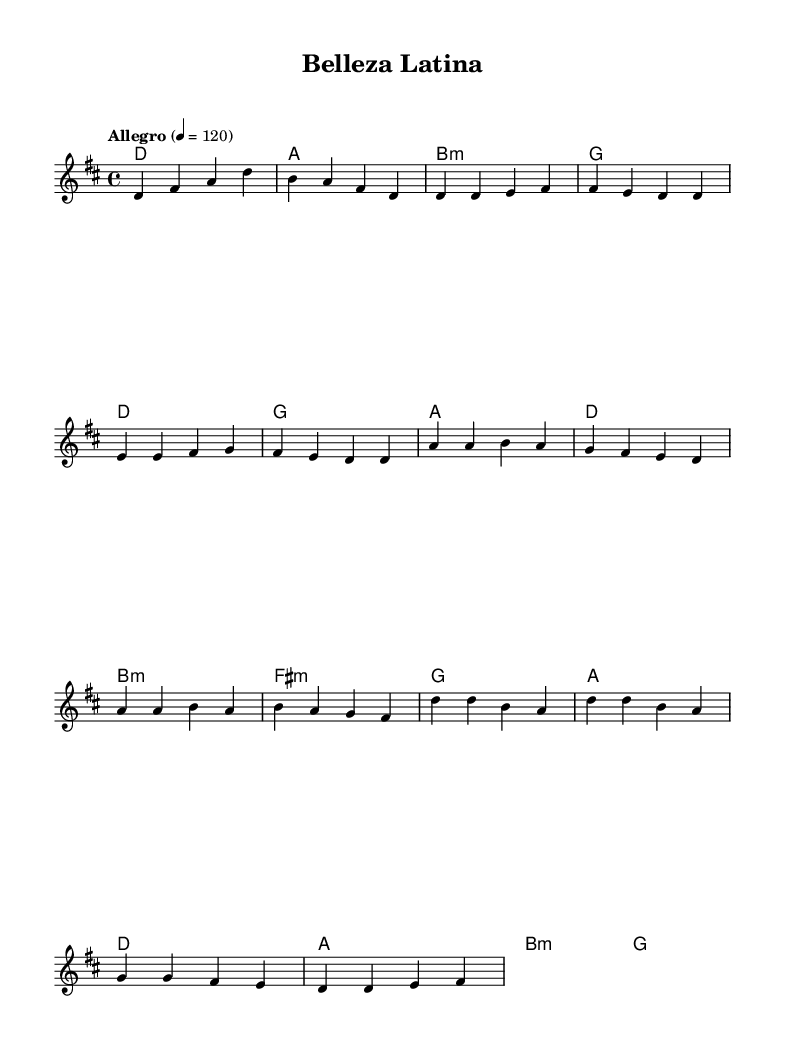What is the key signature of this music? The key signature indicates that the piece is in D major, which has two sharps: F# and C#. You can identify the key signature at the beginning of the staff, where the sharps are written.
Answer: D major What is the time signature of this music? The time signature is found at the beginning of the score, showing how many beats are in each measure. In this case, it is 4/4, meaning there are four beats per measure and the quarter note gets one beat.
Answer: 4/4 What is the tempo marking of this music? The tempo marking appears above the staff, stating "Allegro" with a metronome marking of 120. Allegro suggests a fast, lively tempo, and the number indicates the beats per minute.
Answer: Allegro 4 = 120 How many measures are in the chorus section? To find the number of measures in the chorus, you can visually count the measures in the chorus section of the music. There are a total of four measures in the chorus.
Answer: 4 What type of chord is played in the pre-chorus? The pre-chorus contains multiple chords including B minor and F# minor. These chords are indicated in the harmonies above the melody, showing the harmonic structure for that section.
Answer: B minor Which note is emphasized at the beginning of the melody? The melody starts with the note D, which is prominently featured as the first note in the introduction. This note establishes the tonal center for the piece.
Answer: D What is the mood conveyed by the tempo and style of the music? Based on the fast tempo of Allegro and the lively rhythm, the mood expressed through the music is upbeat and celebratory, which aligns well with themes of beauty and self-confidence.
Answer: Upbeat 